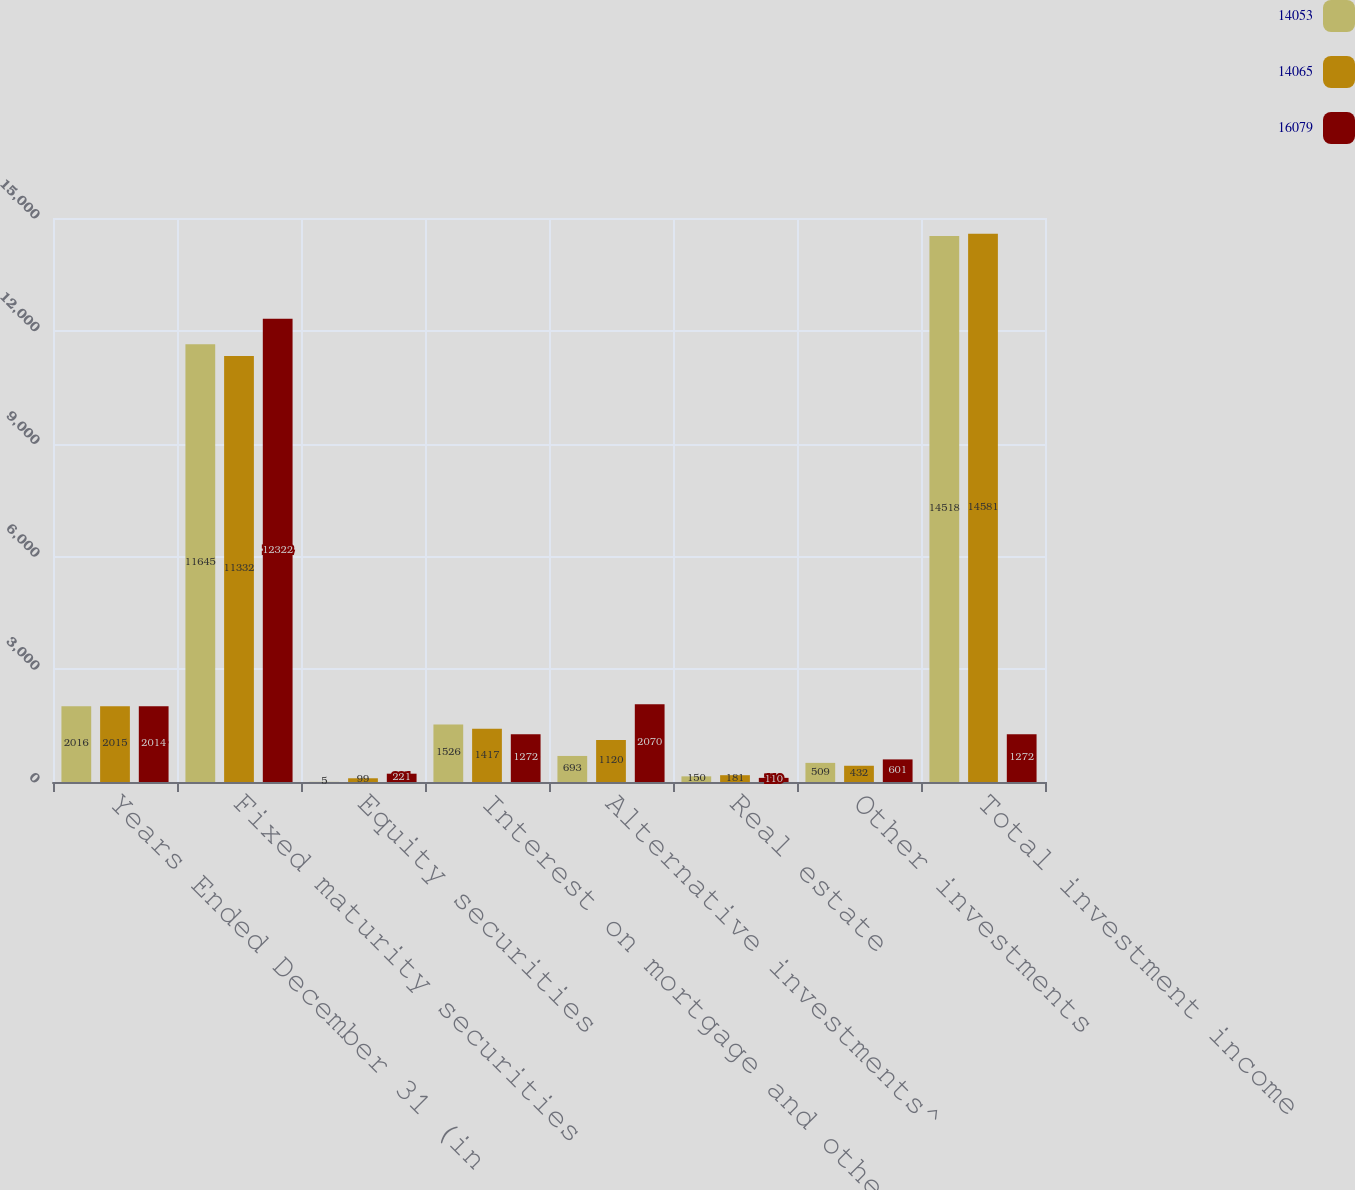<chart> <loc_0><loc_0><loc_500><loc_500><stacked_bar_chart><ecel><fcel>Years Ended December 31 (in<fcel>Fixed maturity securities<fcel>Equity securities<fcel>Interest on mortgage and other<fcel>Alternative investments^<fcel>Real estate<fcel>Other investments<fcel>Total investment income<nl><fcel>14053<fcel>2016<fcel>11645<fcel>5<fcel>1526<fcel>693<fcel>150<fcel>509<fcel>14518<nl><fcel>14065<fcel>2015<fcel>11332<fcel>99<fcel>1417<fcel>1120<fcel>181<fcel>432<fcel>14581<nl><fcel>16079<fcel>2014<fcel>12322<fcel>221<fcel>1272<fcel>2070<fcel>110<fcel>601<fcel>1272<nl></chart> 